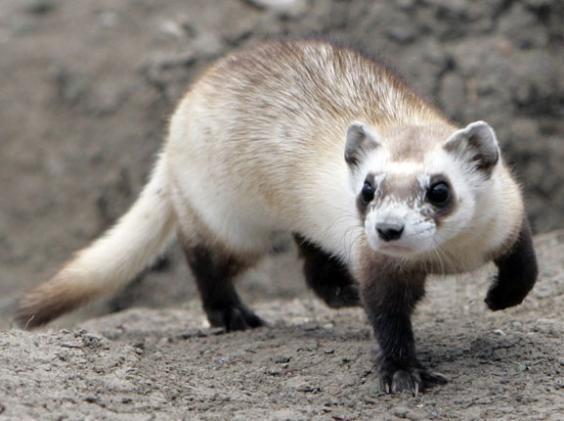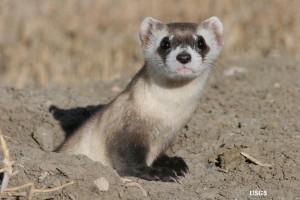The first image is the image on the left, the second image is the image on the right. For the images displayed, is the sentence "The left image contains at least two ferrets." factually correct? Answer yes or no. No. The first image is the image on the left, the second image is the image on the right. Assess this claim about the two images: "At one image shows a group of at least three ferrets inside a brightly colored blue box with white nesting material.". Correct or not? Answer yes or no. No. 